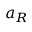<formula> <loc_0><loc_0><loc_500><loc_500>a _ { R }</formula> 